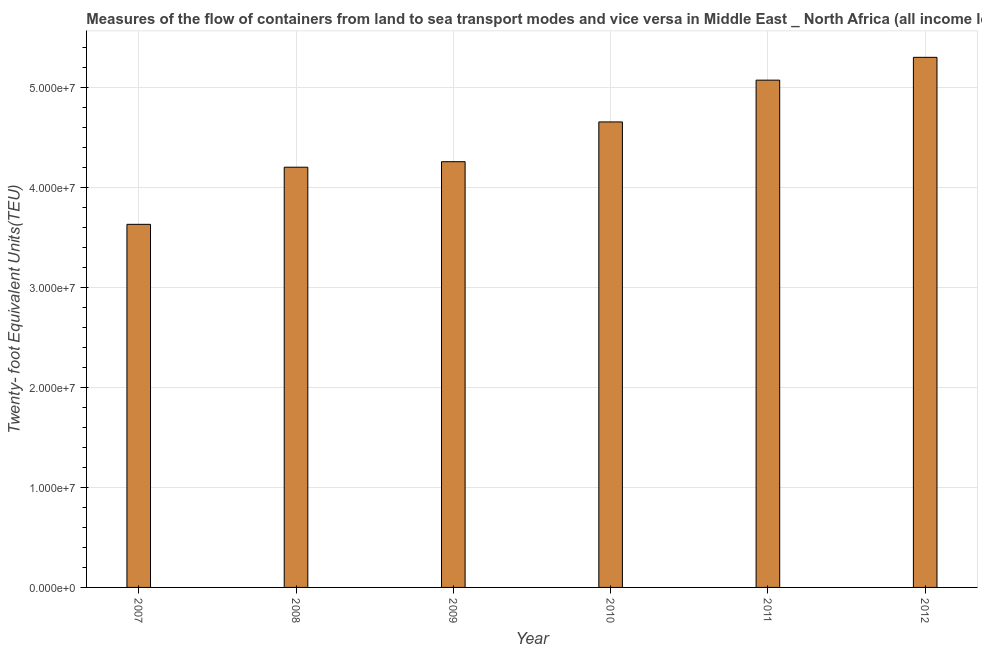Does the graph contain grids?
Offer a very short reply. Yes. What is the title of the graph?
Make the answer very short. Measures of the flow of containers from land to sea transport modes and vice versa in Middle East _ North Africa (all income levels). What is the label or title of the Y-axis?
Your answer should be very brief. Twenty- foot Equivalent Units(TEU). What is the container port traffic in 2012?
Provide a short and direct response. 5.30e+07. Across all years, what is the maximum container port traffic?
Keep it short and to the point. 5.30e+07. Across all years, what is the minimum container port traffic?
Offer a very short reply. 3.63e+07. In which year was the container port traffic maximum?
Your answer should be compact. 2012. What is the sum of the container port traffic?
Your response must be concise. 2.71e+08. What is the difference between the container port traffic in 2008 and 2011?
Give a very brief answer. -8.70e+06. What is the average container port traffic per year?
Offer a terse response. 4.52e+07. What is the median container port traffic?
Ensure brevity in your answer.  4.45e+07. In how many years, is the container port traffic greater than 34000000 TEU?
Offer a terse response. 6. Do a majority of the years between 2008 and 2010 (inclusive) have container port traffic greater than 42000000 TEU?
Offer a terse response. Yes. What is the ratio of the container port traffic in 2007 to that in 2012?
Your response must be concise. 0.69. What is the difference between the highest and the second highest container port traffic?
Give a very brief answer. 2.28e+06. Is the sum of the container port traffic in 2010 and 2012 greater than the maximum container port traffic across all years?
Provide a short and direct response. Yes. What is the difference between the highest and the lowest container port traffic?
Give a very brief answer. 1.67e+07. In how many years, is the container port traffic greater than the average container port traffic taken over all years?
Keep it short and to the point. 3. How many bars are there?
Make the answer very short. 6. How many years are there in the graph?
Offer a terse response. 6. Are the values on the major ticks of Y-axis written in scientific E-notation?
Your answer should be compact. Yes. What is the Twenty- foot Equivalent Units(TEU) of 2007?
Your answer should be very brief. 3.63e+07. What is the Twenty- foot Equivalent Units(TEU) of 2008?
Offer a terse response. 4.20e+07. What is the Twenty- foot Equivalent Units(TEU) of 2009?
Provide a succinct answer. 4.25e+07. What is the Twenty- foot Equivalent Units(TEU) of 2010?
Make the answer very short. 4.65e+07. What is the Twenty- foot Equivalent Units(TEU) in 2011?
Keep it short and to the point. 5.07e+07. What is the Twenty- foot Equivalent Units(TEU) in 2012?
Ensure brevity in your answer.  5.30e+07. What is the difference between the Twenty- foot Equivalent Units(TEU) in 2007 and 2008?
Your answer should be very brief. -5.71e+06. What is the difference between the Twenty- foot Equivalent Units(TEU) in 2007 and 2009?
Ensure brevity in your answer.  -6.26e+06. What is the difference between the Twenty- foot Equivalent Units(TEU) in 2007 and 2010?
Offer a terse response. -1.02e+07. What is the difference between the Twenty- foot Equivalent Units(TEU) in 2007 and 2011?
Your answer should be very brief. -1.44e+07. What is the difference between the Twenty- foot Equivalent Units(TEU) in 2007 and 2012?
Give a very brief answer. -1.67e+07. What is the difference between the Twenty- foot Equivalent Units(TEU) in 2008 and 2009?
Give a very brief answer. -5.50e+05. What is the difference between the Twenty- foot Equivalent Units(TEU) in 2008 and 2010?
Provide a succinct answer. -4.52e+06. What is the difference between the Twenty- foot Equivalent Units(TEU) in 2008 and 2011?
Offer a terse response. -8.70e+06. What is the difference between the Twenty- foot Equivalent Units(TEU) in 2008 and 2012?
Provide a short and direct response. -1.10e+07. What is the difference between the Twenty- foot Equivalent Units(TEU) in 2009 and 2010?
Offer a very short reply. -3.97e+06. What is the difference between the Twenty- foot Equivalent Units(TEU) in 2009 and 2011?
Ensure brevity in your answer.  -8.15e+06. What is the difference between the Twenty- foot Equivalent Units(TEU) in 2009 and 2012?
Your response must be concise. -1.04e+07. What is the difference between the Twenty- foot Equivalent Units(TEU) in 2010 and 2011?
Make the answer very short. -4.18e+06. What is the difference between the Twenty- foot Equivalent Units(TEU) in 2010 and 2012?
Offer a terse response. -6.46e+06. What is the difference between the Twenty- foot Equivalent Units(TEU) in 2011 and 2012?
Your response must be concise. -2.28e+06. What is the ratio of the Twenty- foot Equivalent Units(TEU) in 2007 to that in 2008?
Your answer should be compact. 0.86. What is the ratio of the Twenty- foot Equivalent Units(TEU) in 2007 to that in 2009?
Ensure brevity in your answer.  0.85. What is the ratio of the Twenty- foot Equivalent Units(TEU) in 2007 to that in 2010?
Ensure brevity in your answer.  0.78. What is the ratio of the Twenty- foot Equivalent Units(TEU) in 2007 to that in 2011?
Keep it short and to the point. 0.72. What is the ratio of the Twenty- foot Equivalent Units(TEU) in 2007 to that in 2012?
Make the answer very short. 0.69. What is the ratio of the Twenty- foot Equivalent Units(TEU) in 2008 to that in 2009?
Keep it short and to the point. 0.99. What is the ratio of the Twenty- foot Equivalent Units(TEU) in 2008 to that in 2010?
Provide a short and direct response. 0.9. What is the ratio of the Twenty- foot Equivalent Units(TEU) in 2008 to that in 2011?
Give a very brief answer. 0.83. What is the ratio of the Twenty- foot Equivalent Units(TEU) in 2008 to that in 2012?
Give a very brief answer. 0.79. What is the ratio of the Twenty- foot Equivalent Units(TEU) in 2009 to that in 2010?
Offer a very short reply. 0.92. What is the ratio of the Twenty- foot Equivalent Units(TEU) in 2009 to that in 2011?
Your answer should be very brief. 0.84. What is the ratio of the Twenty- foot Equivalent Units(TEU) in 2009 to that in 2012?
Keep it short and to the point. 0.8. What is the ratio of the Twenty- foot Equivalent Units(TEU) in 2010 to that in 2011?
Make the answer very short. 0.92. What is the ratio of the Twenty- foot Equivalent Units(TEU) in 2010 to that in 2012?
Your answer should be compact. 0.88. What is the ratio of the Twenty- foot Equivalent Units(TEU) in 2011 to that in 2012?
Your response must be concise. 0.96. 